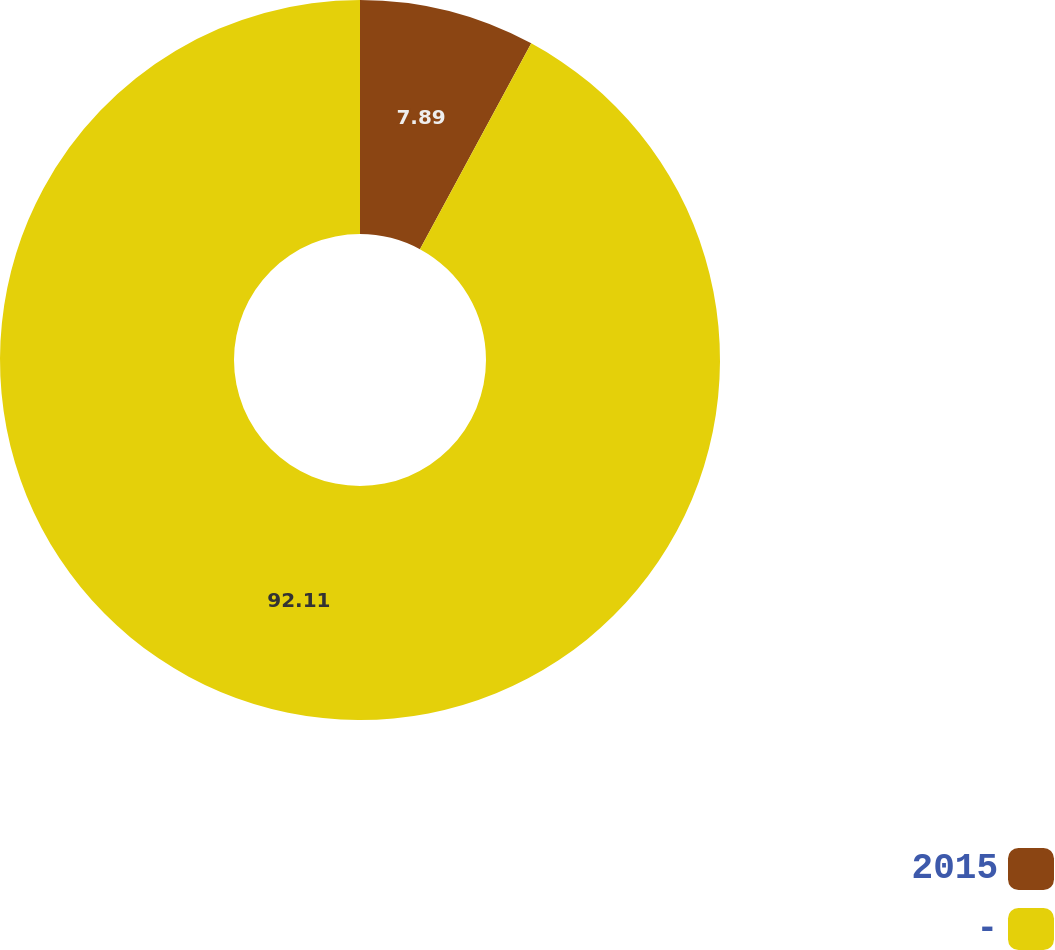Convert chart. <chart><loc_0><loc_0><loc_500><loc_500><pie_chart><fcel>2015<fcel>-<nl><fcel>7.89%<fcel>92.11%<nl></chart> 